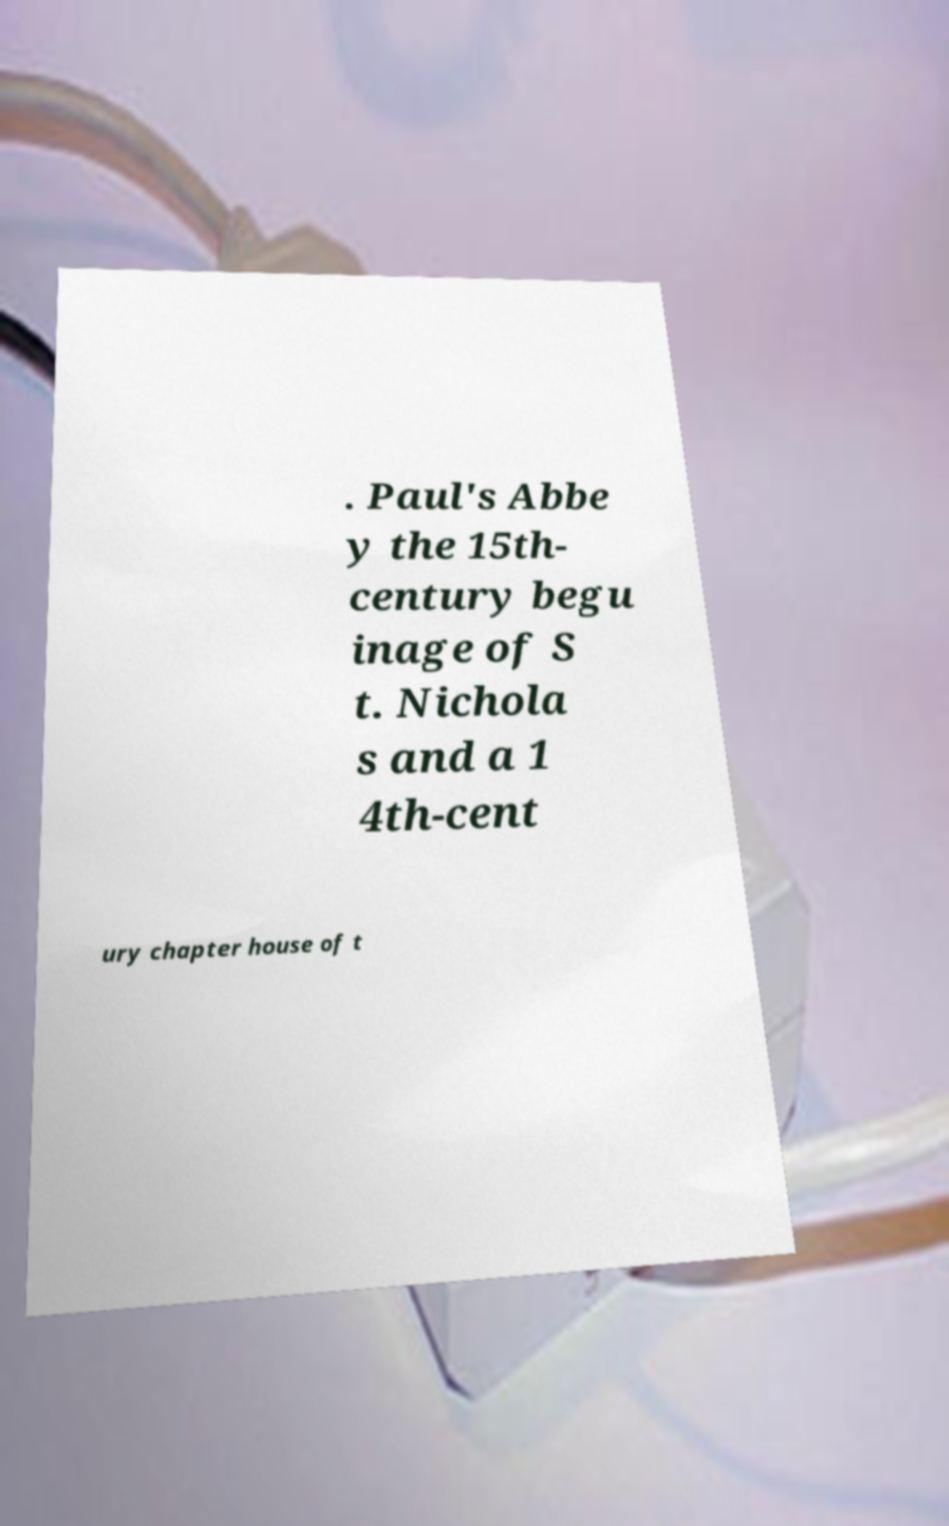Could you assist in decoding the text presented in this image and type it out clearly? . Paul's Abbe y the 15th- century begu inage of S t. Nichola s and a 1 4th-cent ury chapter house of t 